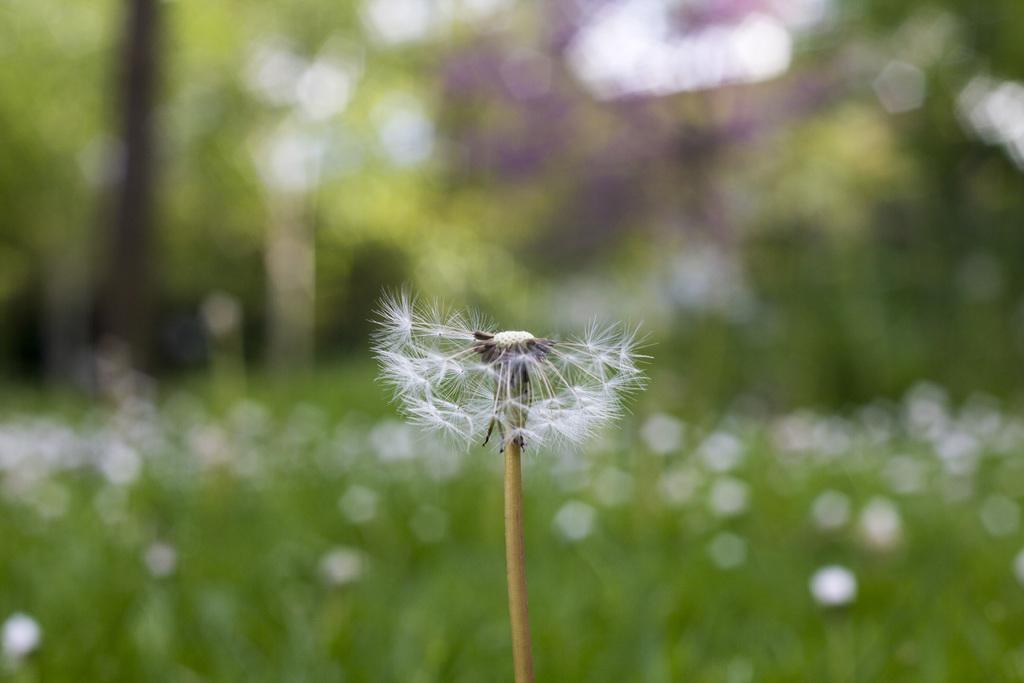Could you give a brief overview of what you see in this image? In this image I can see a white color dandelion plant. 